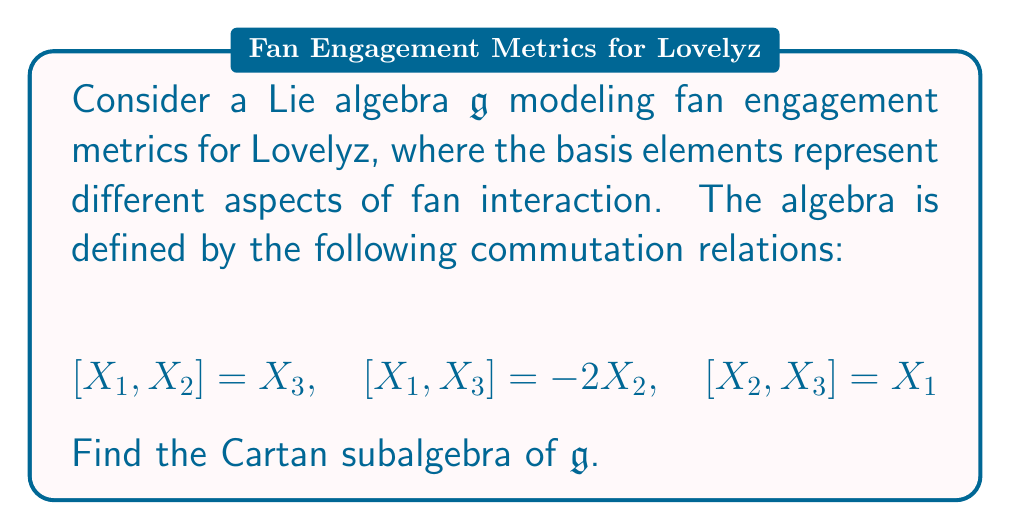Provide a solution to this math problem. To find the Cartan subalgebra of the given Lie algebra $\mathfrak{g}$, we need to follow these steps:

1) Recall that a Cartan subalgebra is a maximal abelian subalgebra consisting of semisimple elements.

2) We first need to find the elements that commute with all other elements in the algebra. Let's consider a general element $H = aX_1 + bX_2 + cX_3$.

3) For $H$ to be in the Cartan subalgebra, it must satisfy $[H, X_i] = 0$ for all $i = 1, 2, 3$.

4) Let's calculate these commutators:

   $[H, X_1] = [aX_1 + bX_2 + cX_3, X_1] = b[X_2, X_1] + c[X_3, X_1] = -bX_3 + 2cX_2$
   
   $[H, X_2] = [aX_1 + bX_2 + cX_3, X_2] = a[X_1, X_2] + c[X_3, X_2] = aX_3 - cX_1$
   
   $[H, X_3] = [aX_1 + bX_2 + cX_3, X_3] = a[X_1, X_3] + b[X_2, X_3] = -2aX_2 + bX_1$

5) For these to be zero, we must have:

   $-b = 0, 2c = 0$
   $a = 0, -c = 0$
   $-2a = 0, b = 0$

6) The only solution to this system is $a = b = c = 0$.

7) This means that the only element that commutes with all others is the zero element.

8) Therefore, the Cartan subalgebra of $\mathfrak{g}$ is trivial, consisting only of the zero element.
Answer: The Cartan subalgebra of $\mathfrak{g}$ is $\{0\}$. 